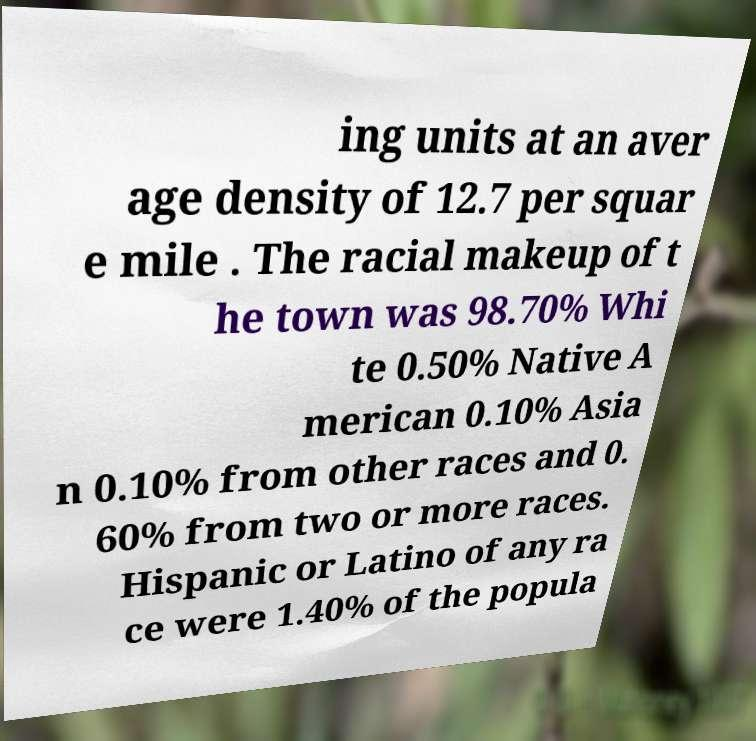I need the written content from this picture converted into text. Can you do that? ing units at an aver age density of 12.7 per squar e mile . The racial makeup of t he town was 98.70% Whi te 0.50% Native A merican 0.10% Asia n 0.10% from other races and 0. 60% from two or more races. Hispanic or Latino of any ra ce were 1.40% of the popula 